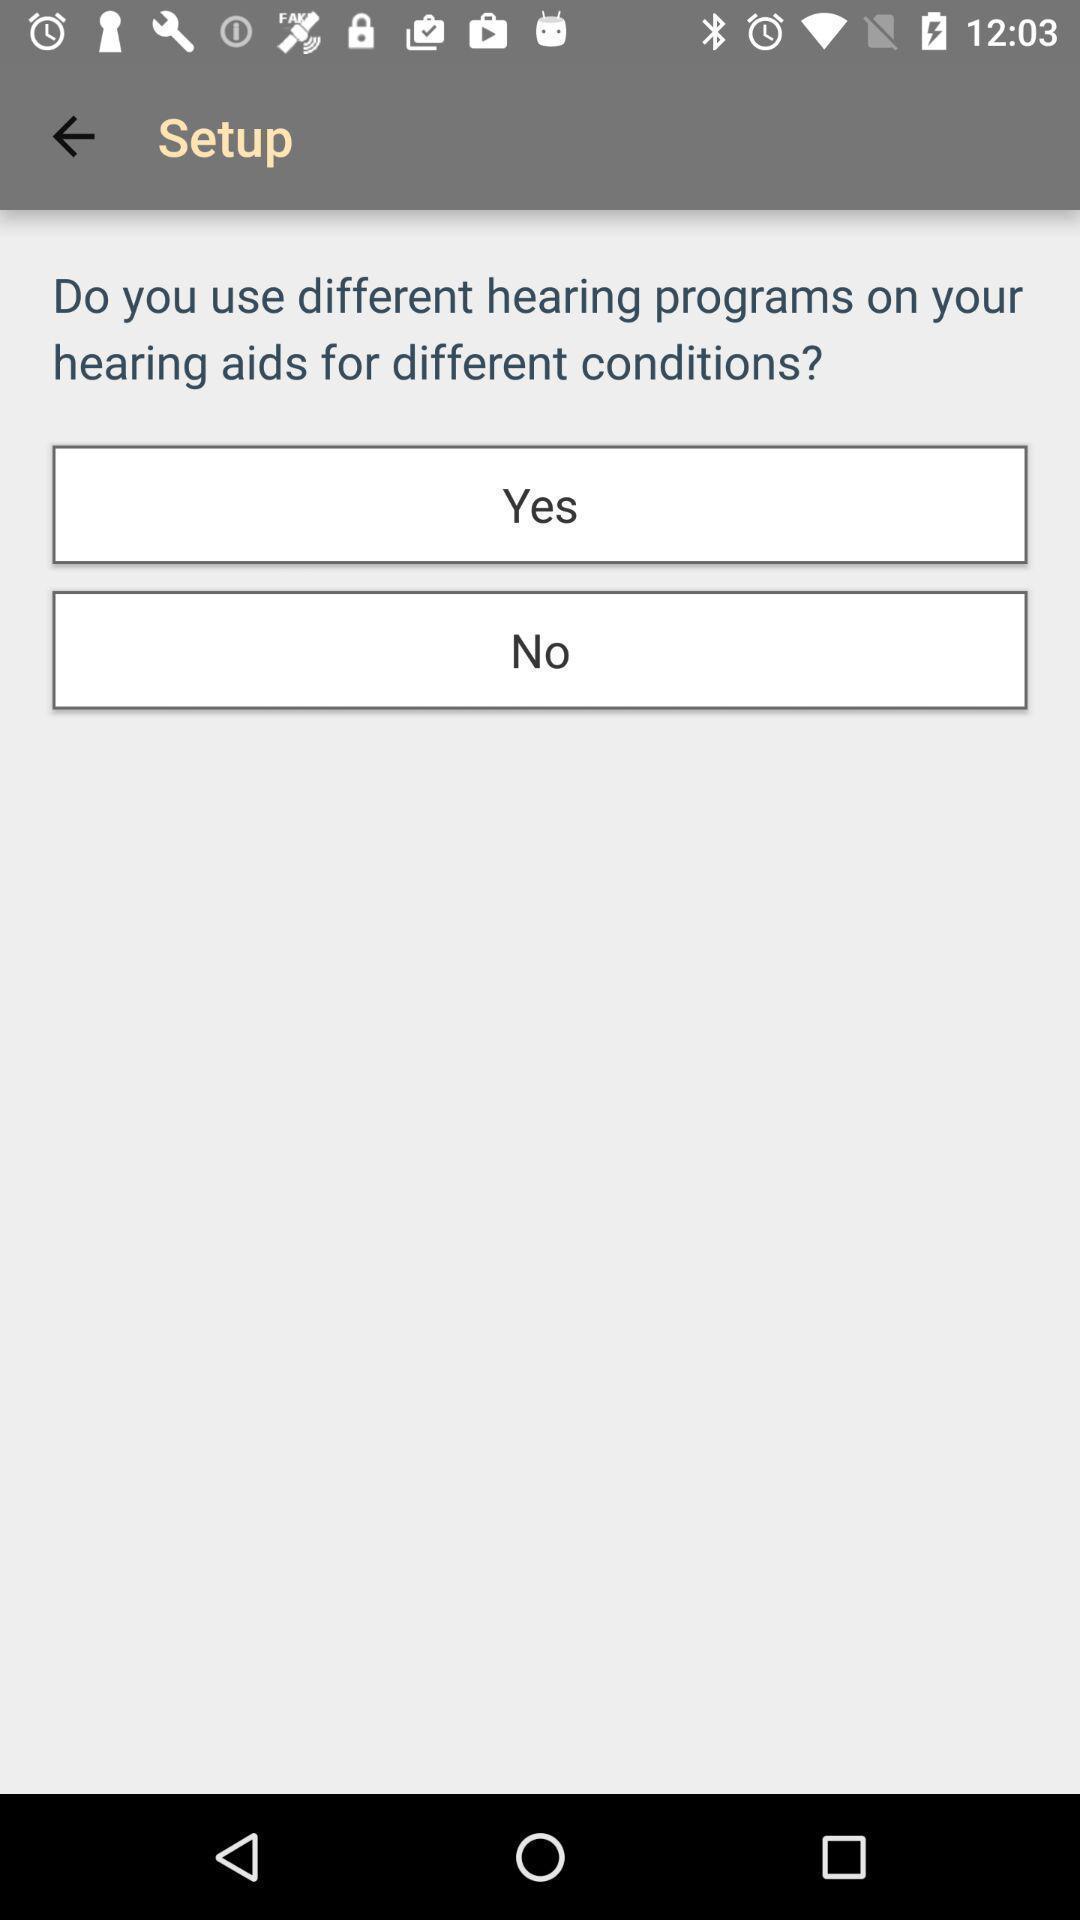Tell me about the visual elements in this screen capture. Setup page of a hearing aid app. 